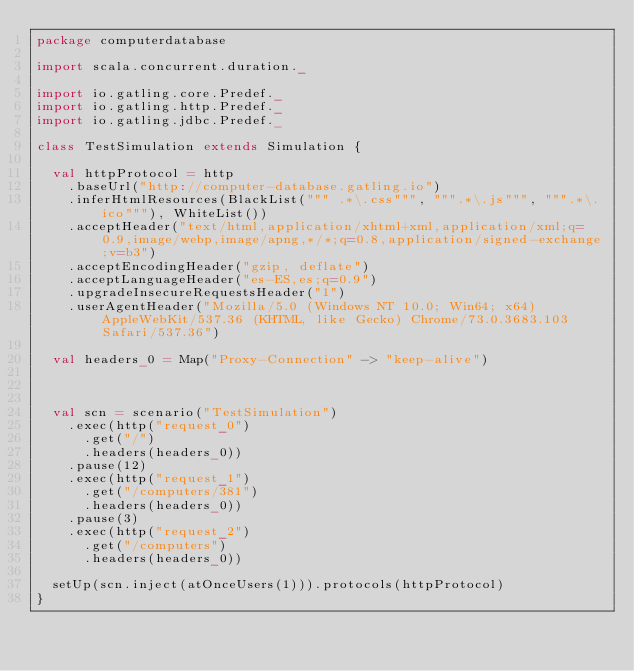<code> <loc_0><loc_0><loc_500><loc_500><_Scala_>package computerdatabase

import scala.concurrent.duration._

import io.gatling.core.Predef._
import io.gatling.http.Predef._
import io.gatling.jdbc.Predef._

class TestSimulation extends Simulation {

	val httpProtocol = http
		.baseUrl("http://computer-database.gatling.io")
		.inferHtmlResources(BlackList(""" .*\.css""", """.*\.js""", """.*\.ico"""), WhiteList())
		.acceptHeader("text/html,application/xhtml+xml,application/xml;q=0.9,image/webp,image/apng,*/*;q=0.8,application/signed-exchange;v=b3")
		.acceptEncodingHeader("gzip, deflate")
		.acceptLanguageHeader("es-ES,es;q=0.9")
		.upgradeInsecureRequestsHeader("1")
		.userAgentHeader("Mozilla/5.0 (Windows NT 10.0; Win64; x64) AppleWebKit/537.36 (KHTML, like Gecko) Chrome/73.0.3683.103 Safari/537.36")

	val headers_0 = Map("Proxy-Connection" -> "keep-alive")



	val scn = scenario("TestSimulation")
		.exec(http("request_0")
			.get("/")
			.headers(headers_0))
		.pause(12)
		.exec(http("request_1")
			.get("/computers/381")
			.headers(headers_0))
		.pause(3)
		.exec(http("request_2")
			.get("/computers")
			.headers(headers_0))

	setUp(scn.inject(atOnceUsers(1))).protocols(httpProtocol)
}</code> 